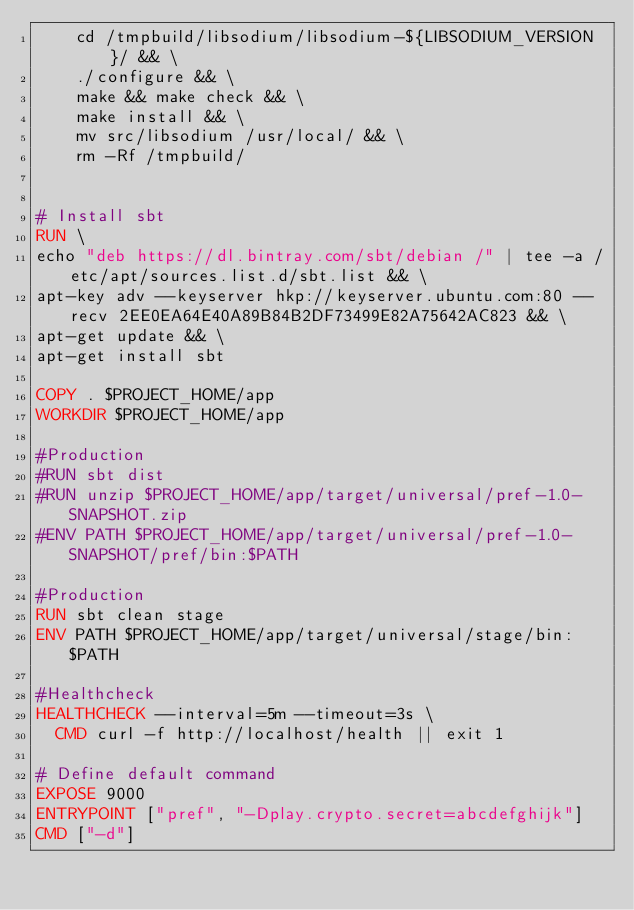Convert code to text. <code><loc_0><loc_0><loc_500><loc_500><_Dockerfile_>    cd /tmpbuild/libsodium/libsodium-${LIBSODIUM_VERSION}/ && \
    ./configure && \
    make && make check && \
    make install && \
    mv src/libsodium /usr/local/ && \
    rm -Rf /tmpbuild/


# Install sbt
RUN \
echo "deb https://dl.bintray.com/sbt/debian /" | tee -a /etc/apt/sources.list.d/sbt.list && \
apt-key adv --keyserver hkp://keyserver.ubuntu.com:80 --recv 2EE0EA64E40A89B84B2DF73499E82A75642AC823 && \
apt-get update && \
apt-get install sbt

COPY . $PROJECT_HOME/app
WORKDIR $PROJECT_HOME/app

#Production
#RUN sbt dist 
#RUN unzip $PROJECT_HOME/app/target/universal/pref-1.0-SNAPSHOT.zip
#ENV PATH $PROJECT_HOME/app/target/universal/pref-1.0-SNAPSHOT/pref/bin:$PATH

#Production
RUN sbt clean stage
ENV PATH $PROJECT_HOME/app/target/universal/stage/bin:$PATH
 
#Healthcheck
HEALTHCHECK --interval=5m --timeout=3s \
  CMD curl -f http://localhost/health || exit 1

# Define default command
EXPOSE 9000
ENTRYPOINT ["pref", "-Dplay.crypto.secret=abcdefghijk"]
CMD ["-d"]
</code> 